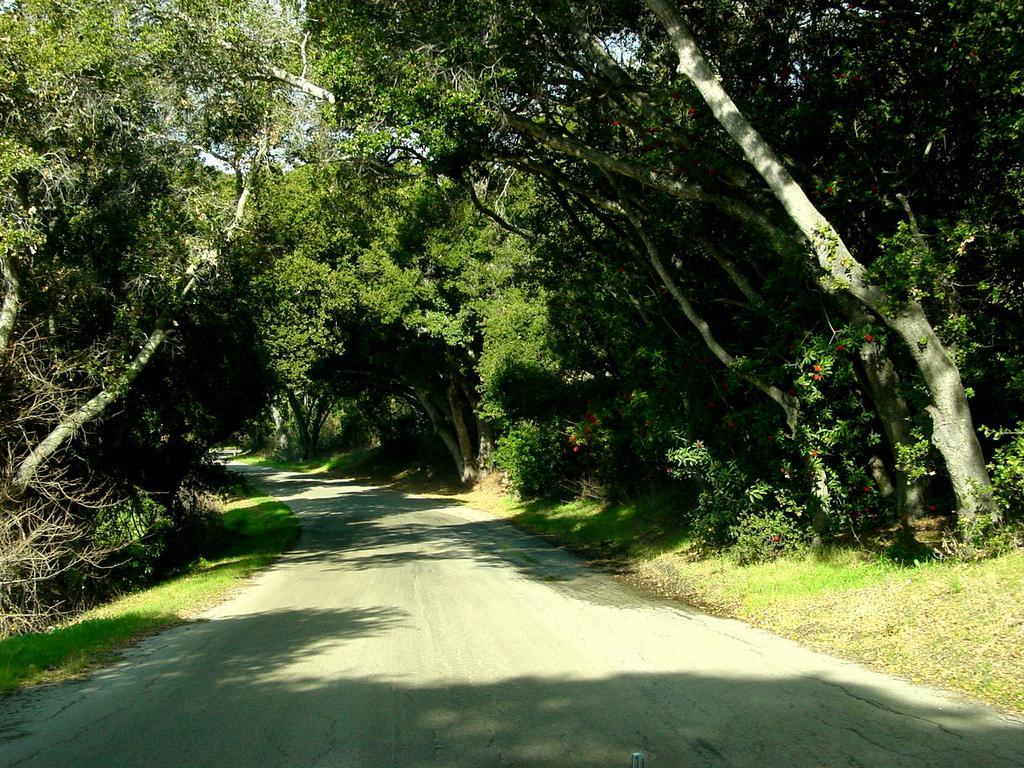Could you give a brief overview of what you see in this image? In this picture we can see a road and aside to this road we can see trees and grass. 